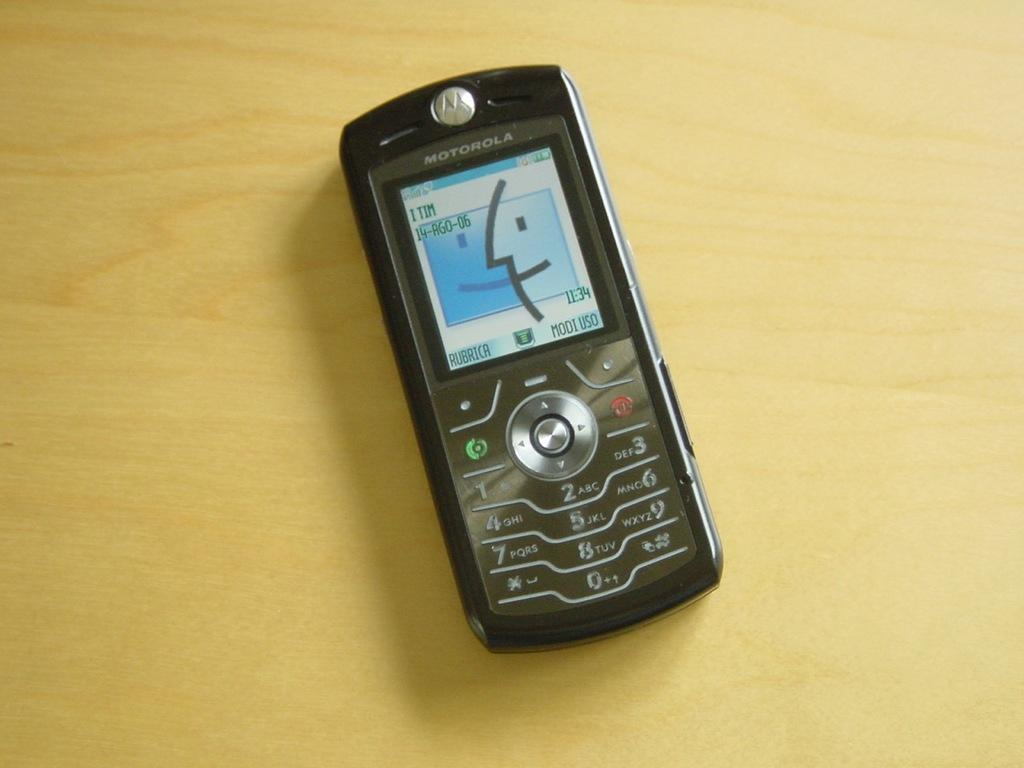<image>
Share a concise interpretation of the image provided. an old black motorola cell phone sits on the counter 